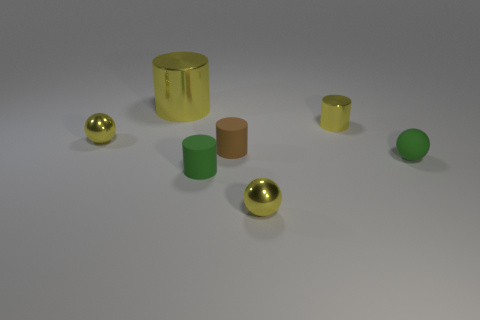Add 3 green spheres. How many objects exist? 10 Subtract all balls. How many objects are left? 4 Subtract all small cylinders. Subtract all brown objects. How many objects are left? 3 Add 5 big things. How many big things are left? 6 Add 2 big yellow blocks. How many big yellow blocks exist? 2 Subtract 0 brown balls. How many objects are left? 7 